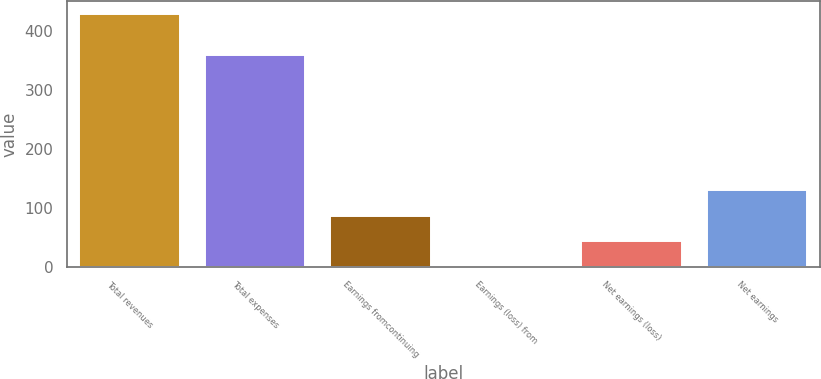Convert chart to OTSL. <chart><loc_0><loc_0><loc_500><loc_500><bar_chart><fcel>Total revenues<fcel>Total expenses<fcel>Earnings fromcontinuing<fcel>Earnings (loss) from<fcel>Net earnings (loss)<fcel>Net earnings<nl><fcel>428.9<fcel>359.6<fcel>86.5<fcel>0.9<fcel>43.7<fcel>129.3<nl></chart> 